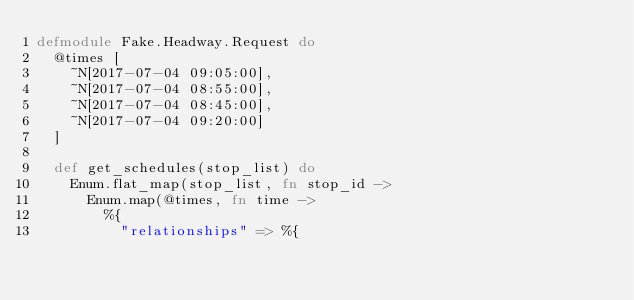Convert code to text. <code><loc_0><loc_0><loc_500><loc_500><_Elixir_>defmodule Fake.Headway.Request do
  @times [
    ~N[2017-07-04 09:05:00],
    ~N[2017-07-04 08:55:00],
    ~N[2017-07-04 08:45:00],
    ~N[2017-07-04 09:20:00]
  ]

  def get_schedules(stop_list) do
    Enum.flat_map(stop_list, fn stop_id ->
      Enum.map(@times, fn time ->
        %{
          "relationships" => %{</code> 